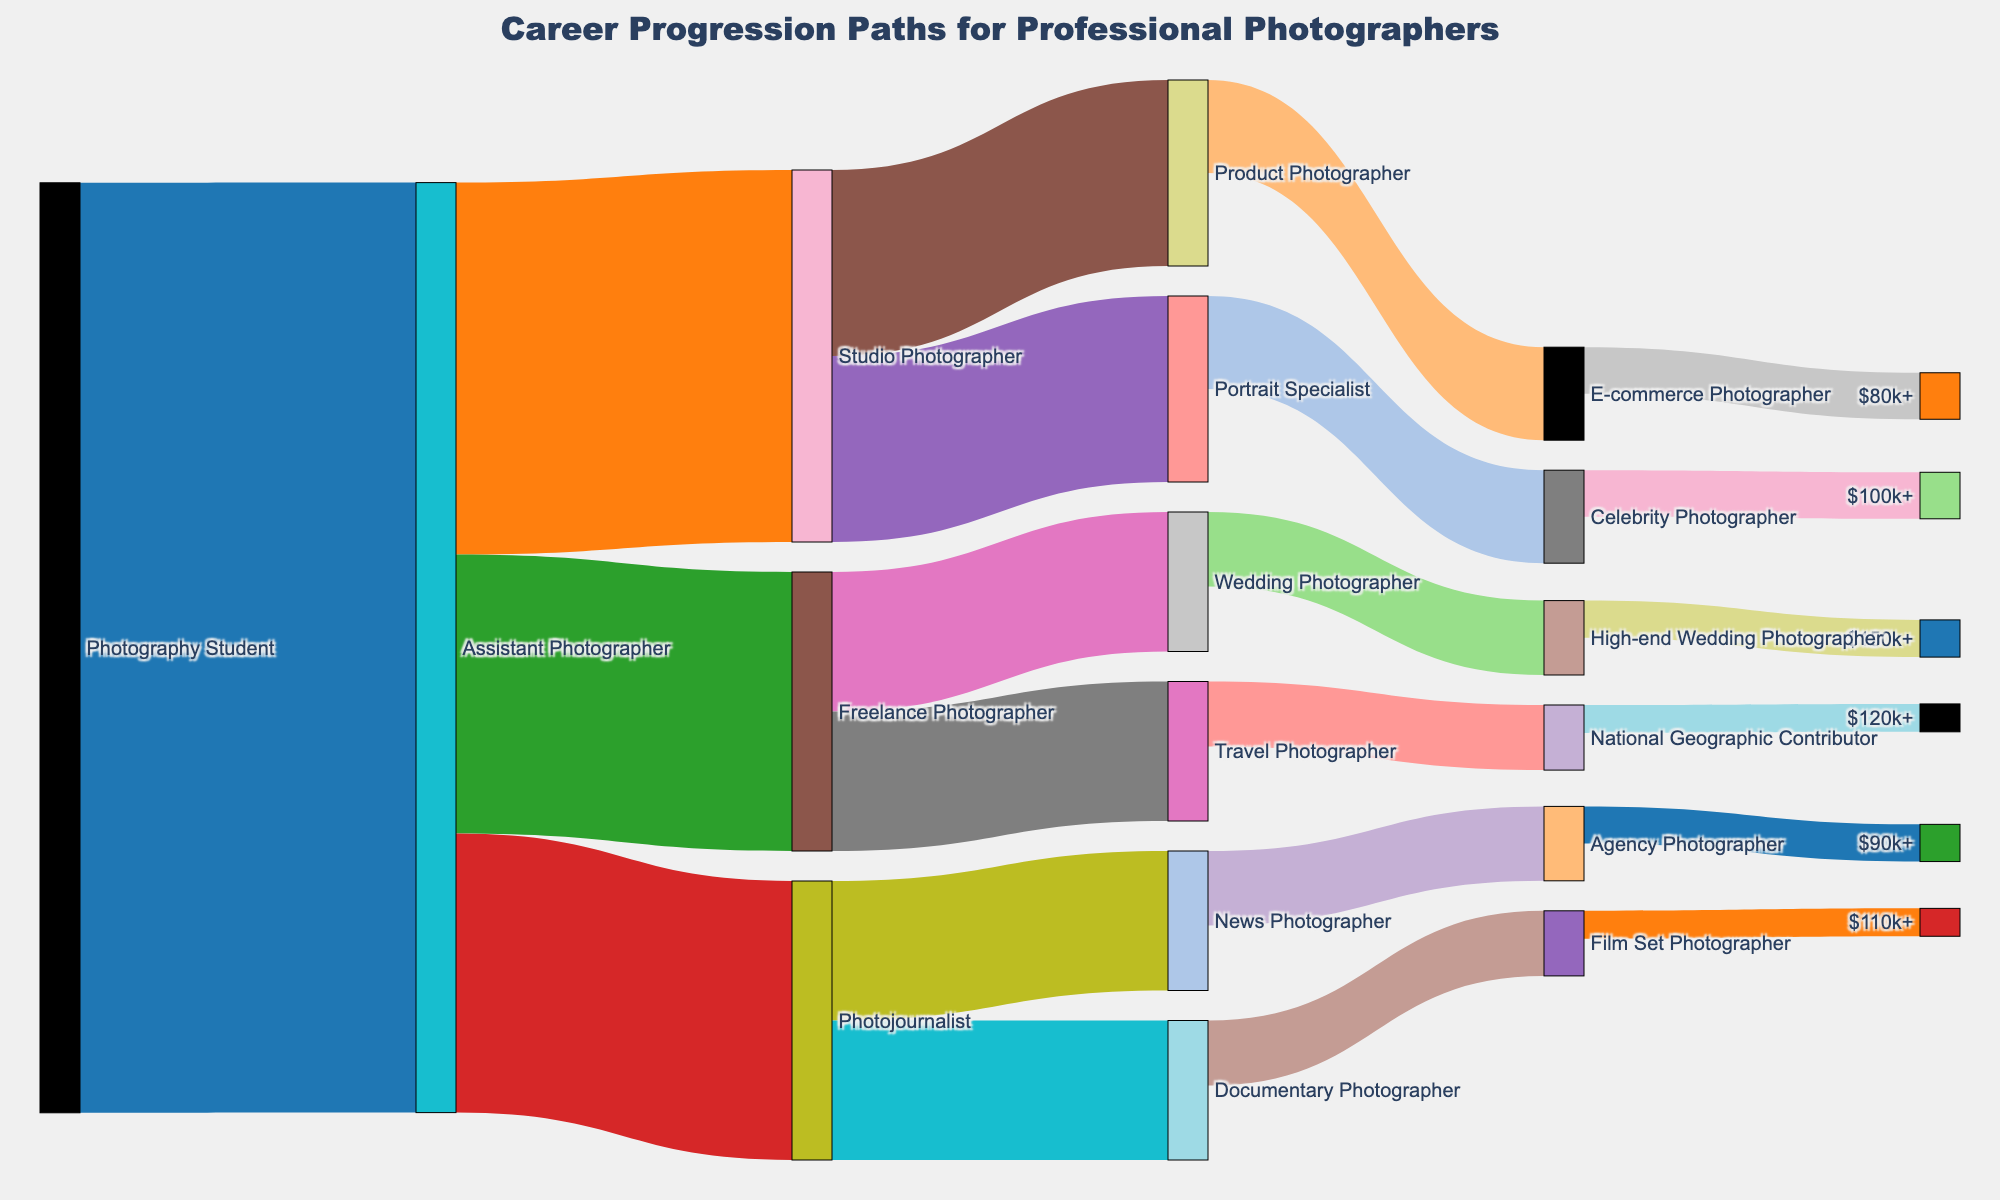What is the title of the Sankey diagram? The title is located at the top of the diagram and it summarizes the visual representation of the data.
Answer: Career Progression Paths for Professional Photographers Which career path has the highest progression from Assistant Photographer? Look at the three branches extending from Assistant Photographer and compare the values. The branch with the highest value represents the most common progression.
Answer: Studio Photographer What specializations can a Studio Photographer advance to? Trace the paths leading from Studio Photographer to see which target nodes it connects to.
Answer: Portrait Specialist, Product Photographer How many paths lead to an income of $100k+? Identify the target node labeled $100k+ and count the number of paths leading to it.
Answer: 1 What is the total number of individuals that progress from Assistant Photographer to any specialization? Sum the values of all branches extending from Assistant Photographer.
Answer: 100 Which specialization offers the highest income based on this chart? Identify the target node with the highest income value in the label and trace back to its corresponding specialization.
Answer: High-end Wedding Photographer How many individuals progress from Freelance Photographer to travel-related specializations? Identify the paths extending from Freelance Photographer to travel-related specializations and sum their values.
Answer: 15 (Travel Photographer) Compare the number of individuals progressing to Product Photographer and E-commerce Photographer. Which path is more common? Look at the values on the paths leading to Product Photographer and E-commerce Photographer. Compare these values to determine which is greater.
Answer: Product Photographer What percentage of Assistant Photographers become Photojournalists? Take the value for the branch leading to Photojournalist, divide by the total number of Assistant Photographers, and multiply by 100 to get the percentage.
Answer: 30% If you sum all the values leading to high-income levels ($80k+ and above), what is the total number? Identify all the nodes representing income levels of $80k+ and sum their values to get the total number.
Answer: 24 